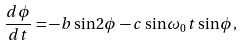<formula> <loc_0><loc_0><loc_500><loc_500>\frac { d \phi } { d t } = - b \sin 2 \phi - c \sin \omega _ { 0 } t \sin \phi ,</formula> 